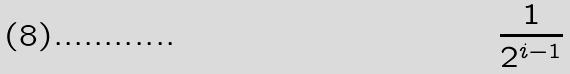<formula> <loc_0><loc_0><loc_500><loc_500>\frac { 1 } { 2 ^ { i - 1 } }</formula> 